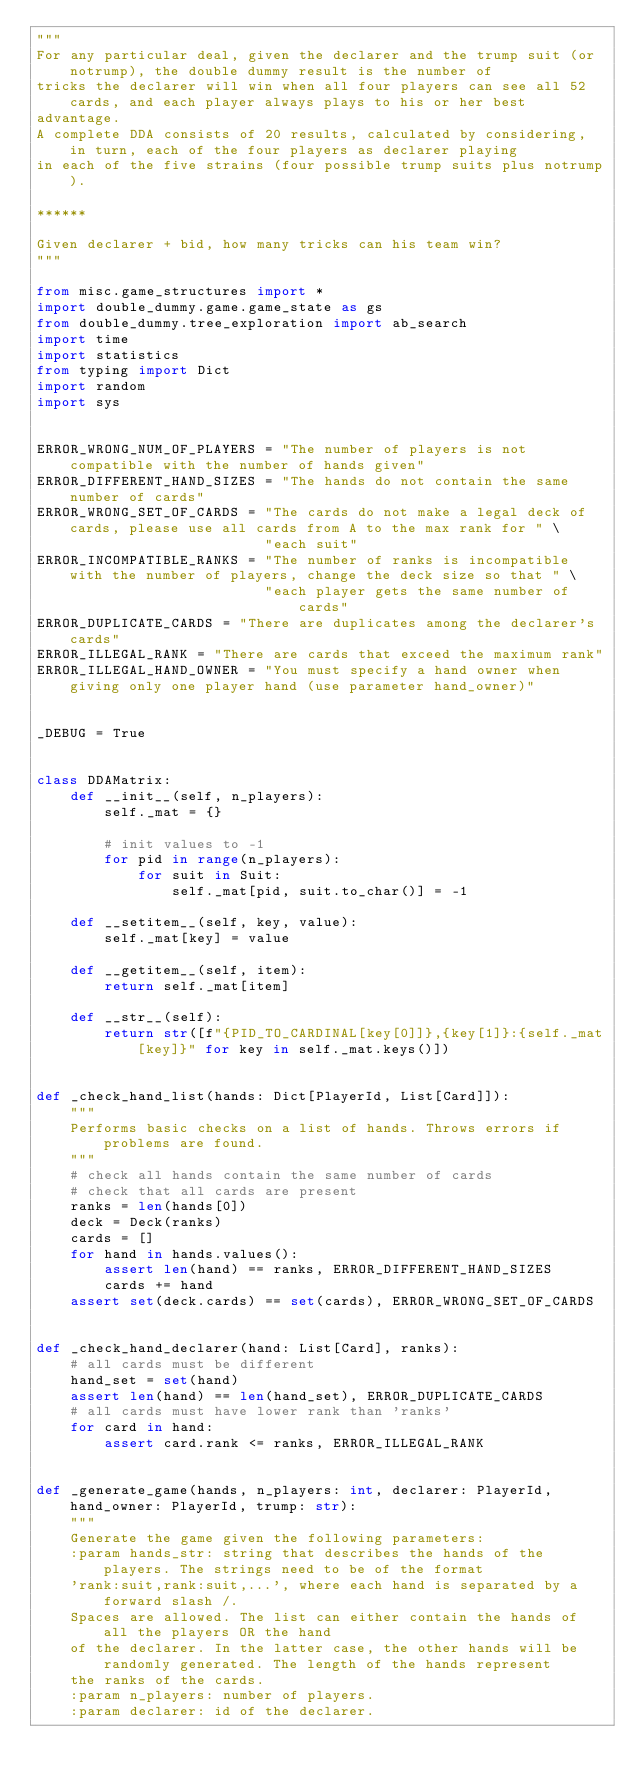Convert code to text. <code><loc_0><loc_0><loc_500><loc_500><_Python_>"""
For any particular deal, given the declarer and the trump suit (or notrump), the double dummy result is the number of
tricks the declarer will win when all four players can see all 52 cards, and each player always plays to his or her best
advantage.
A complete DDA consists of 20 results, calculated by considering, in turn, each of the four players as declarer playing
in each of the five strains (four possible trump suits plus notrump).

******

Given declarer + bid, how many tricks can his team win?
"""

from misc.game_structures import *
import double_dummy.game.game_state as gs
from double_dummy.tree_exploration import ab_search
import time
import statistics
from typing import Dict
import random
import sys


ERROR_WRONG_NUM_OF_PLAYERS = "The number of players is not compatible with the number of hands given"
ERROR_DIFFERENT_HAND_SIZES = "The hands do not contain the same number of cards"
ERROR_WRONG_SET_OF_CARDS = "The cards do not make a legal deck of cards, please use all cards from A to the max rank for " \
                           "each suit"
ERROR_INCOMPATIBLE_RANKS = "The number of ranks is incompatible with the number of players, change the deck size so that " \
                           "each player gets the same number of cards"
ERROR_DUPLICATE_CARDS = "There are duplicates among the declarer's cards"
ERROR_ILLEGAL_RANK = "There are cards that exceed the maximum rank"
ERROR_ILLEGAL_HAND_OWNER = "You must specify a hand owner when giving only one player hand (use parameter hand_owner)"


_DEBUG = True


class DDAMatrix:
    def __init__(self, n_players):
        self._mat = {}

        # init values to -1
        for pid in range(n_players):
            for suit in Suit:
                self._mat[pid, suit.to_char()] = -1

    def __setitem__(self, key, value):
        self._mat[key] = value

    def __getitem__(self, item):
        return self._mat[item]

    def __str__(self):
        return str([f"{PID_TO_CARDINAL[key[0]]},{key[1]}:{self._mat[key]}" for key in self._mat.keys()])


def _check_hand_list(hands: Dict[PlayerId, List[Card]]):
    """
    Performs basic checks on a list of hands. Throws errors if problems are found.
    """
    # check all hands contain the same number of cards
    # check that all cards are present
    ranks = len(hands[0])
    deck = Deck(ranks)
    cards = []
    for hand in hands.values():
        assert len(hand) == ranks, ERROR_DIFFERENT_HAND_SIZES
        cards += hand
    assert set(deck.cards) == set(cards), ERROR_WRONG_SET_OF_CARDS


def _check_hand_declarer(hand: List[Card], ranks):
    # all cards must be different
    hand_set = set(hand)
    assert len(hand) == len(hand_set), ERROR_DUPLICATE_CARDS
    # all cards must have lower rank than 'ranks'
    for card in hand:
        assert card.rank <= ranks, ERROR_ILLEGAL_RANK


def _generate_game(hands, n_players: int, declarer: PlayerId, hand_owner: PlayerId, trump: str):
    """
    Generate the game given the following parameters:
    :param hands_str: string that describes the hands of the players. The strings need to be of the format
    'rank:suit,rank:suit,...', where each hand is separated by a forward slash /.
    Spaces are allowed. The list can either contain the hands of all the players OR the hand
    of the declarer. In the latter case, the other hands will be randomly generated. The length of the hands represent
    the ranks of the cards.
    :param n_players: number of players.
    :param declarer: id of the declarer.</code> 